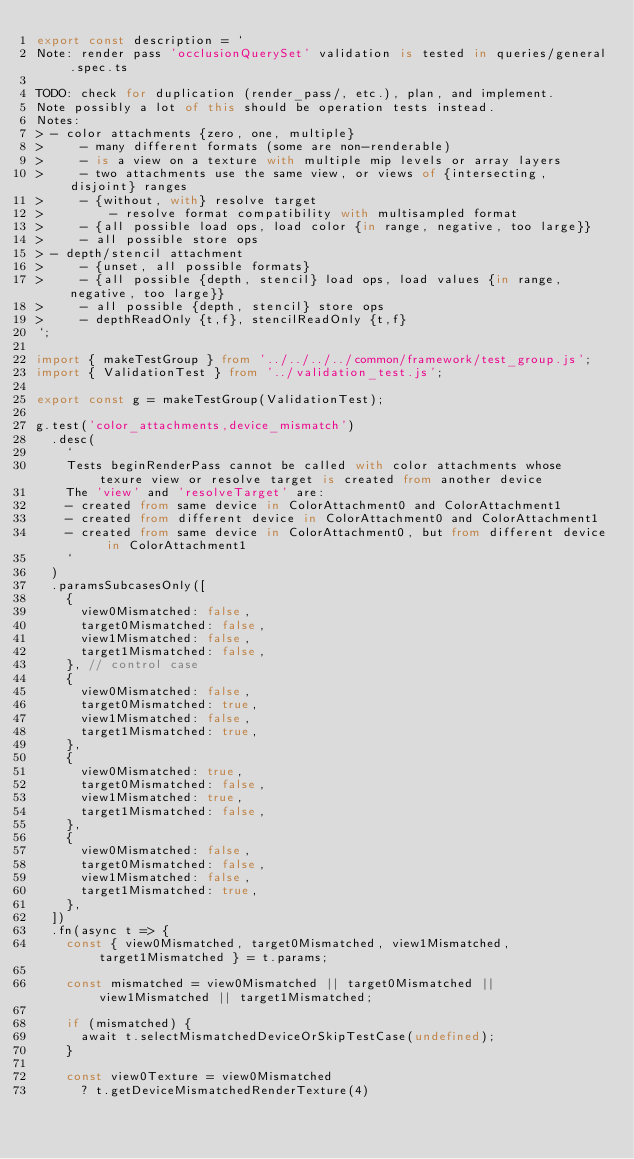<code> <loc_0><loc_0><loc_500><loc_500><_TypeScript_>export const description = `
Note: render pass 'occlusionQuerySet' validation is tested in queries/general.spec.ts

TODO: check for duplication (render_pass/, etc.), plan, and implement.
Note possibly a lot of this should be operation tests instead.
Notes:
> - color attachments {zero, one, multiple}
>     - many different formats (some are non-renderable)
>     - is a view on a texture with multiple mip levels or array layers
>     - two attachments use the same view, or views of {intersecting, disjoint} ranges
>     - {without, with} resolve target
>         - resolve format compatibility with multisampled format
>     - {all possible load ops, load color {in range, negative, too large}}
>     - all possible store ops
> - depth/stencil attachment
>     - {unset, all possible formats}
>     - {all possible {depth, stencil} load ops, load values {in range, negative, too large}}
>     - all possible {depth, stencil} store ops
>     - depthReadOnly {t,f}, stencilReadOnly {t,f}
`;

import { makeTestGroup } from '../../../../common/framework/test_group.js';
import { ValidationTest } from '../validation_test.js';

export const g = makeTestGroup(ValidationTest);

g.test('color_attachments,device_mismatch')
  .desc(
    `
    Tests beginRenderPass cannot be called with color attachments whose texure view or resolve target is created from another device
    The 'view' and 'resolveTarget' are:
    - created from same device in ColorAttachment0 and ColorAttachment1
    - created from different device in ColorAttachment0 and ColorAttachment1
    - created from same device in ColorAttachment0, but from different device in ColorAttachment1
    `
  )
  .paramsSubcasesOnly([
    {
      view0Mismatched: false,
      target0Mismatched: false,
      view1Mismatched: false,
      target1Mismatched: false,
    }, // control case
    {
      view0Mismatched: false,
      target0Mismatched: true,
      view1Mismatched: false,
      target1Mismatched: true,
    },
    {
      view0Mismatched: true,
      target0Mismatched: false,
      view1Mismatched: true,
      target1Mismatched: false,
    },
    {
      view0Mismatched: false,
      target0Mismatched: false,
      view1Mismatched: false,
      target1Mismatched: true,
    },
  ])
  .fn(async t => {
    const { view0Mismatched, target0Mismatched, view1Mismatched, target1Mismatched } = t.params;

    const mismatched = view0Mismatched || target0Mismatched || view1Mismatched || target1Mismatched;

    if (mismatched) {
      await t.selectMismatchedDeviceOrSkipTestCase(undefined);
    }

    const view0Texture = view0Mismatched
      ? t.getDeviceMismatchedRenderTexture(4)</code> 